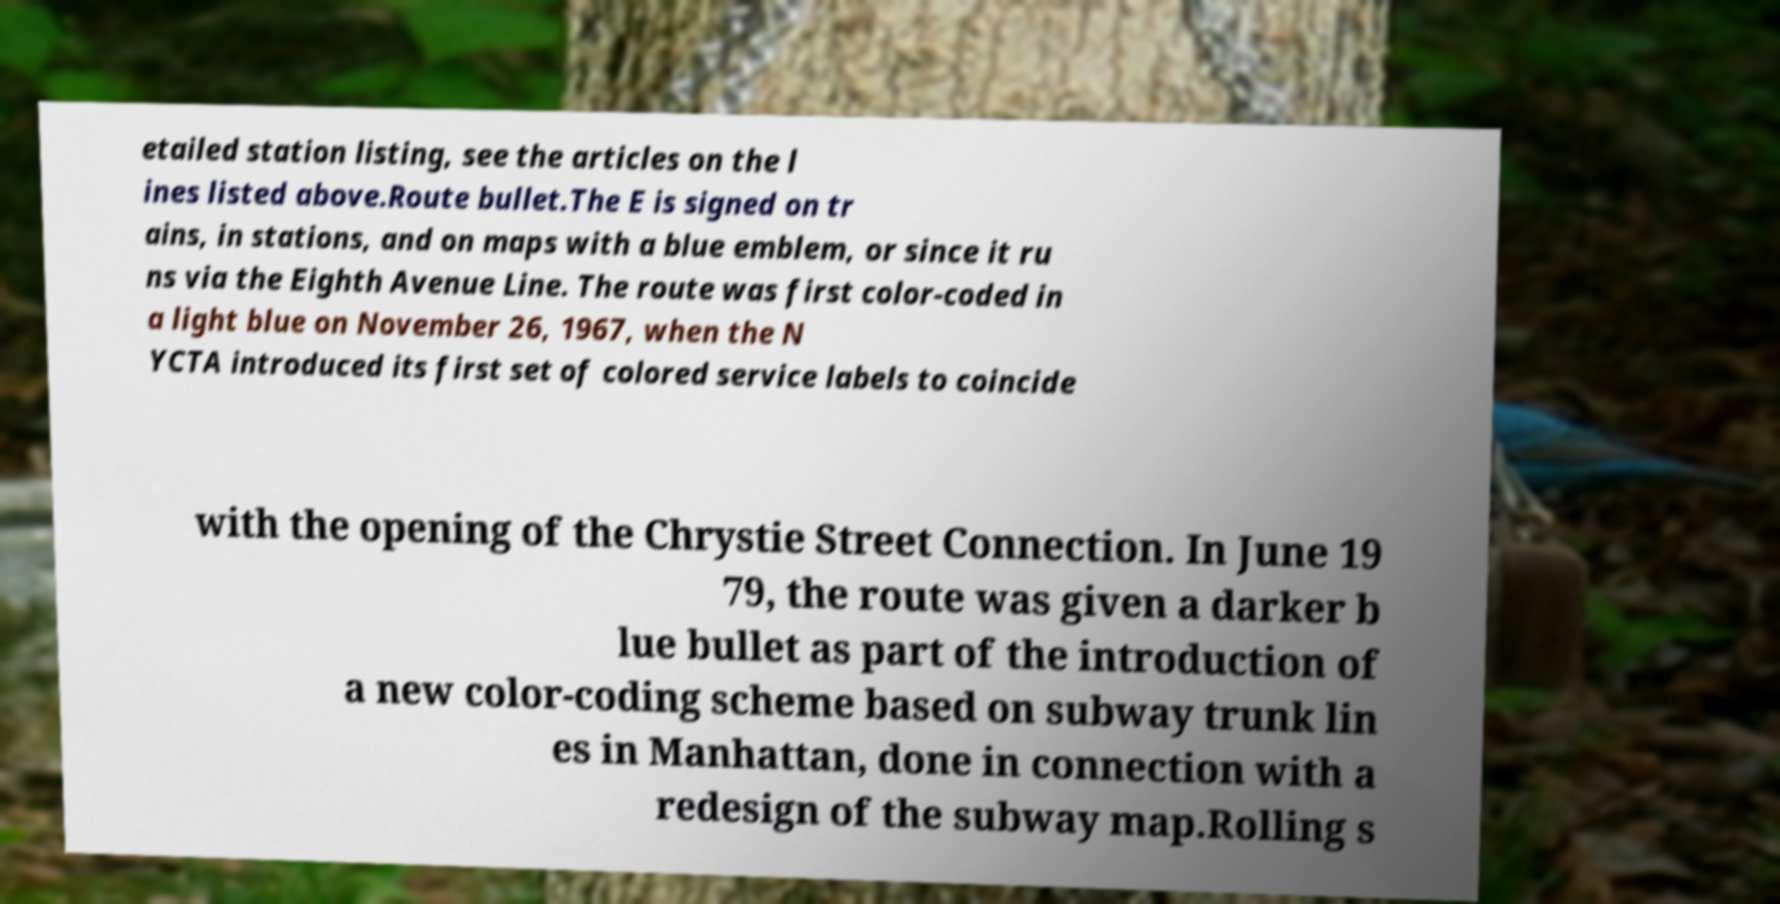Could you assist in decoding the text presented in this image and type it out clearly? etailed station listing, see the articles on the l ines listed above.Route bullet.The E is signed on tr ains, in stations, and on maps with a blue emblem, or since it ru ns via the Eighth Avenue Line. The route was first color-coded in a light blue on November 26, 1967, when the N YCTA introduced its first set of colored service labels to coincide with the opening of the Chrystie Street Connection. In June 19 79, the route was given a darker b lue bullet as part of the introduction of a new color-coding scheme based on subway trunk lin es in Manhattan, done in connection with a redesign of the subway map.Rolling s 